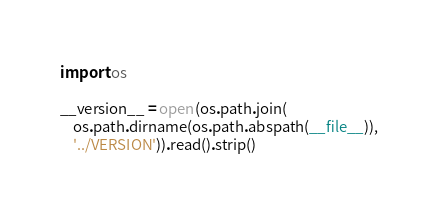Convert code to text. <code><loc_0><loc_0><loc_500><loc_500><_Python_>import os

__version__ = open(os.path.join(
    os.path.dirname(os.path.abspath(__file__)),
    '../VERSION')).read().strip()
</code> 